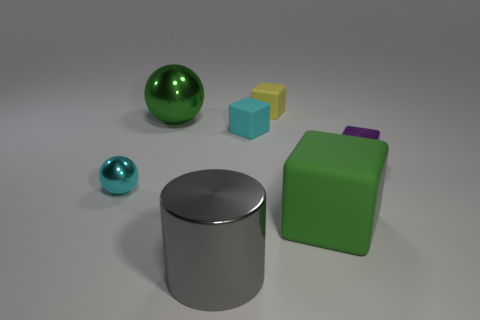Subtract 1 blocks. How many blocks are left? 3 Subtract all red cubes. Subtract all brown cylinders. How many cubes are left? 4 Add 1 tiny metallic balls. How many objects exist? 8 Subtract all spheres. How many objects are left? 5 Subtract 0 red spheres. How many objects are left? 7 Subtract all small cyan metal spheres. Subtract all small purple cubes. How many objects are left? 5 Add 7 gray objects. How many gray objects are left? 8 Add 3 small metal blocks. How many small metal blocks exist? 4 